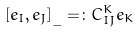Convert formula to latex. <formula><loc_0><loc_0><loc_500><loc_500>[ e _ { I } , e _ { J } ] _ { \_ } = \colon C _ { { I } { J } } ^ { K } e _ { K }</formula> 